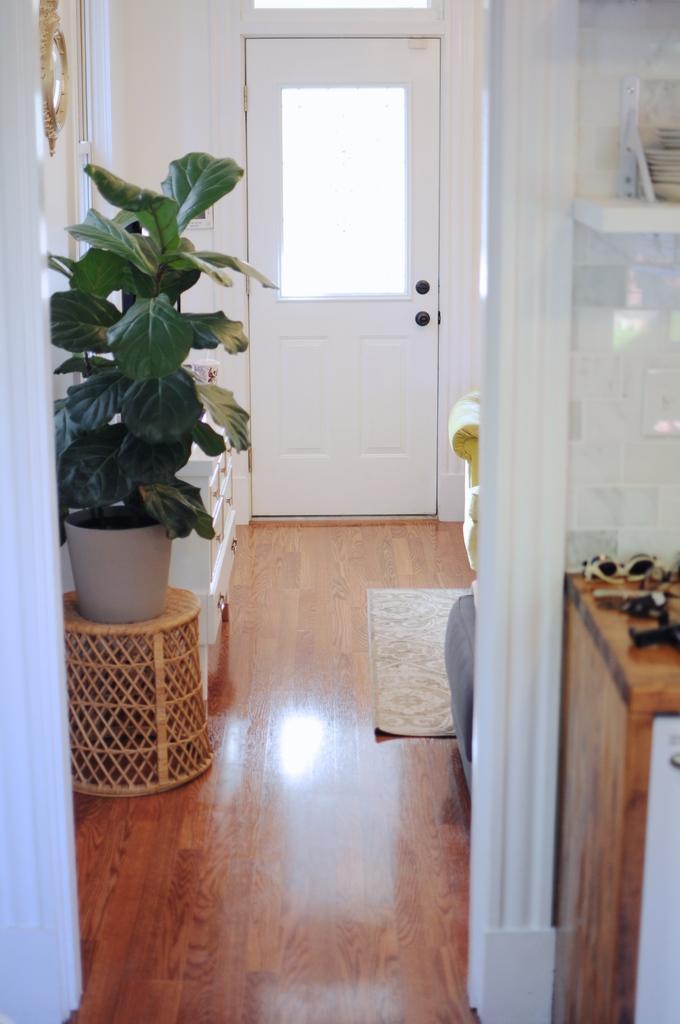Can you describe this image briefly? In the picture we can find a room with door, wall, plant and a wooden floor with mat and somethings on the table. 